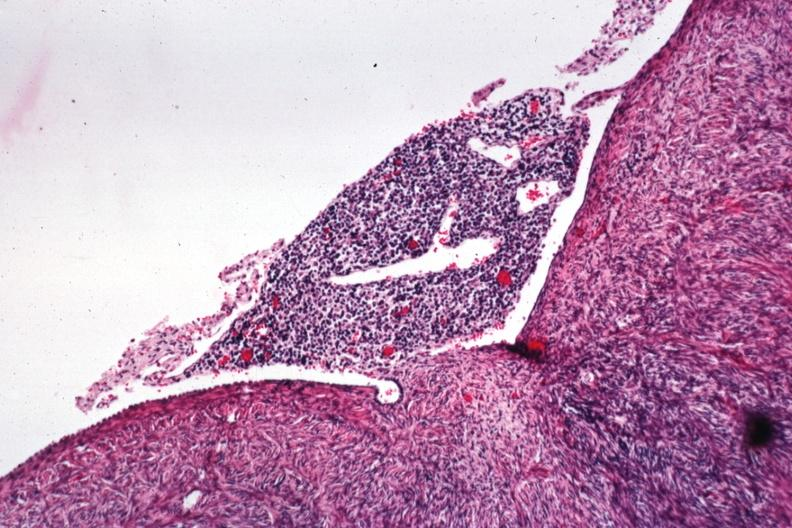where is this from?
Answer the question using a single word or phrase. Female reproductive system 